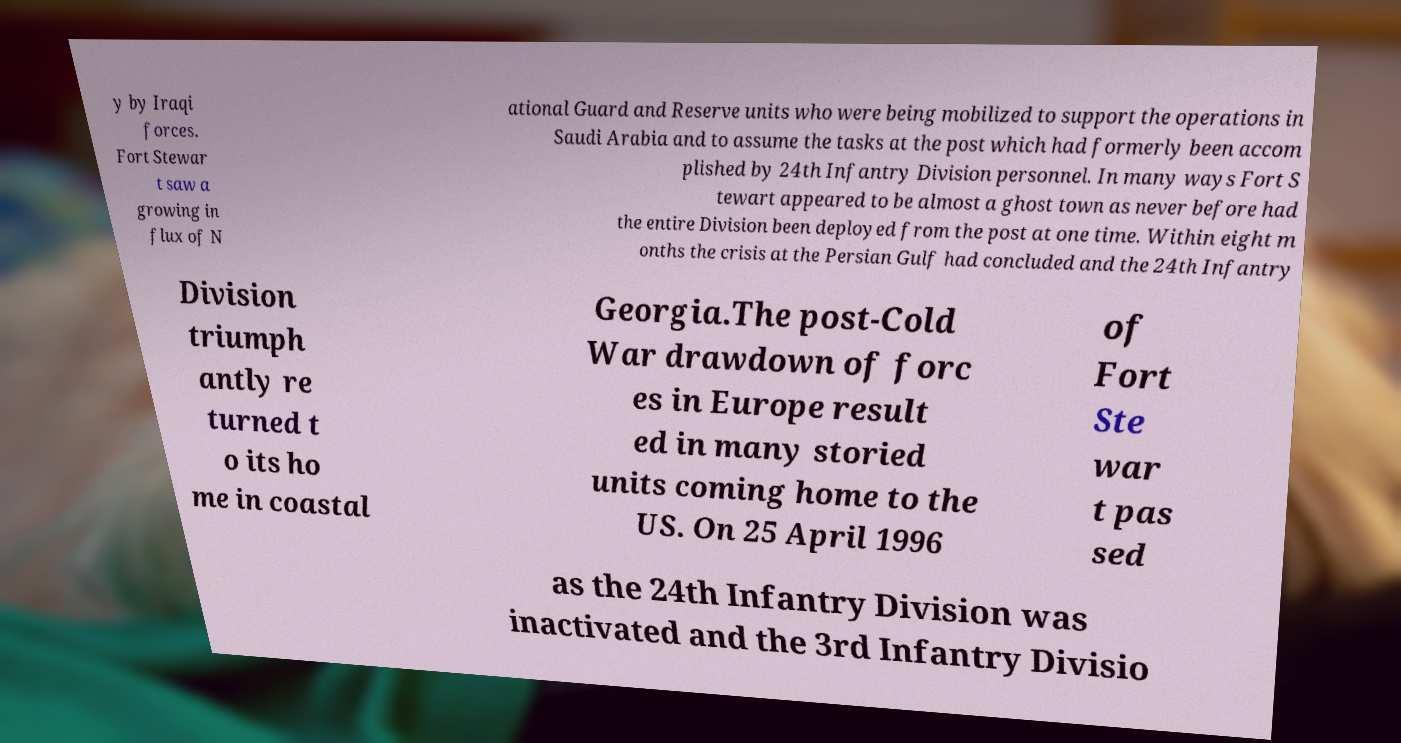What messages or text are displayed in this image? I need them in a readable, typed format. y by Iraqi forces. Fort Stewar t saw a growing in flux of N ational Guard and Reserve units who were being mobilized to support the operations in Saudi Arabia and to assume the tasks at the post which had formerly been accom plished by 24th Infantry Division personnel. In many ways Fort S tewart appeared to be almost a ghost town as never before had the entire Division been deployed from the post at one time. Within eight m onths the crisis at the Persian Gulf had concluded and the 24th Infantry Division triumph antly re turned t o its ho me in coastal Georgia.The post-Cold War drawdown of forc es in Europe result ed in many storied units coming home to the US. On 25 April 1996 of Fort Ste war t pas sed as the 24th Infantry Division was inactivated and the 3rd Infantry Divisio 